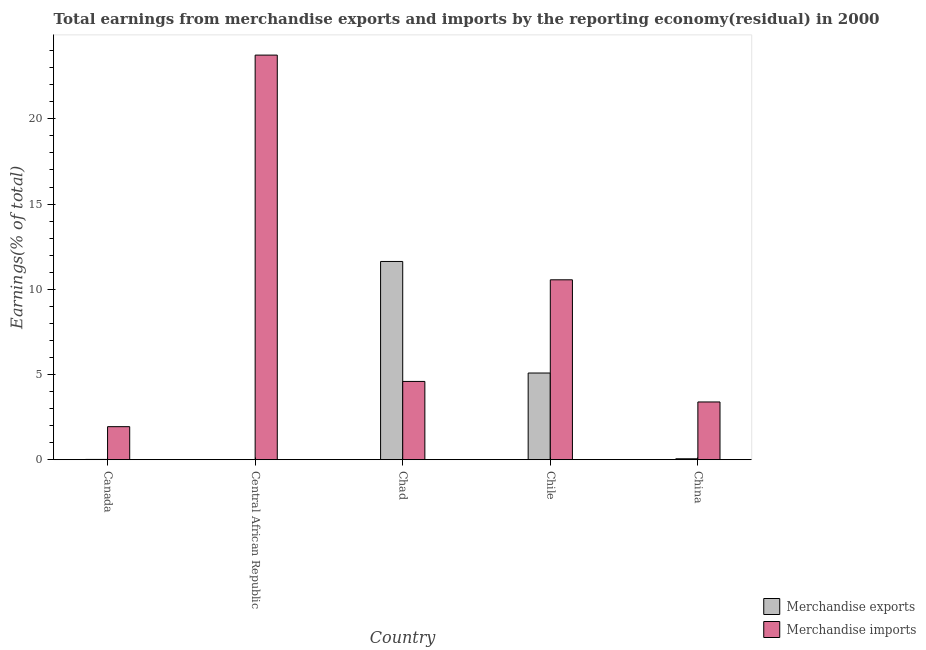How many different coloured bars are there?
Provide a succinct answer. 2. How many bars are there on the 2nd tick from the left?
Provide a succinct answer. 2. What is the label of the 3rd group of bars from the left?
Offer a very short reply. Chad. In how many cases, is the number of bars for a given country not equal to the number of legend labels?
Your answer should be very brief. 0. What is the earnings from merchandise exports in Central African Republic?
Your response must be concise. 0. Across all countries, what is the maximum earnings from merchandise imports?
Your answer should be compact. 23.74. Across all countries, what is the minimum earnings from merchandise imports?
Offer a terse response. 1.94. In which country was the earnings from merchandise exports maximum?
Your answer should be very brief. Chad. What is the total earnings from merchandise imports in the graph?
Your response must be concise. 44.21. What is the difference between the earnings from merchandise exports in Chad and that in China?
Give a very brief answer. 11.58. What is the difference between the earnings from merchandise imports in Chad and the earnings from merchandise exports in Canada?
Ensure brevity in your answer.  4.58. What is the average earnings from merchandise imports per country?
Offer a terse response. 8.84. What is the difference between the earnings from merchandise exports and earnings from merchandise imports in Chad?
Make the answer very short. 7.04. In how many countries, is the earnings from merchandise imports greater than 2 %?
Ensure brevity in your answer.  4. What is the ratio of the earnings from merchandise exports in Central African Republic to that in Chile?
Your response must be concise. 0. Is the difference between the earnings from merchandise exports in Chad and China greater than the difference between the earnings from merchandise imports in Chad and China?
Provide a short and direct response. Yes. What is the difference between the highest and the second highest earnings from merchandise exports?
Offer a very short reply. 6.55. What is the difference between the highest and the lowest earnings from merchandise imports?
Make the answer very short. 21.8. Is the sum of the earnings from merchandise imports in Canada and China greater than the maximum earnings from merchandise exports across all countries?
Your answer should be compact. No. What does the 2nd bar from the right in Central African Republic represents?
Ensure brevity in your answer.  Merchandise exports. How many bars are there?
Keep it short and to the point. 10. What is the difference between two consecutive major ticks on the Y-axis?
Offer a very short reply. 5. Does the graph contain any zero values?
Provide a short and direct response. No. Does the graph contain grids?
Your response must be concise. No. How many legend labels are there?
Provide a succinct answer. 2. What is the title of the graph?
Make the answer very short. Total earnings from merchandise exports and imports by the reporting economy(residual) in 2000. What is the label or title of the Y-axis?
Keep it short and to the point. Earnings(% of total). What is the Earnings(% of total) of Merchandise exports in Canada?
Offer a terse response. 0.02. What is the Earnings(% of total) of Merchandise imports in Canada?
Provide a short and direct response. 1.94. What is the Earnings(% of total) in Merchandise exports in Central African Republic?
Provide a succinct answer. 0. What is the Earnings(% of total) of Merchandise imports in Central African Republic?
Your answer should be compact. 23.74. What is the Earnings(% of total) of Merchandise exports in Chad?
Keep it short and to the point. 11.63. What is the Earnings(% of total) in Merchandise imports in Chad?
Your answer should be very brief. 4.59. What is the Earnings(% of total) in Merchandise exports in Chile?
Provide a short and direct response. 5.09. What is the Earnings(% of total) of Merchandise imports in Chile?
Your answer should be compact. 10.56. What is the Earnings(% of total) of Merchandise exports in China?
Your response must be concise. 0.05. What is the Earnings(% of total) in Merchandise imports in China?
Your answer should be very brief. 3.39. Across all countries, what is the maximum Earnings(% of total) of Merchandise exports?
Offer a very short reply. 11.63. Across all countries, what is the maximum Earnings(% of total) of Merchandise imports?
Offer a terse response. 23.74. Across all countries, what is the minimum Earnings(% of total) of Merchandise exports?
Your response must be concise. 0. Across all countries, what is the minimum Earnings(% of total) of Merchandise imports?
Provide a succinct answer. 1.94. What is the total Earnings(% of total) of Merchandise exports in the graph?
Provide a succinct answer. 16.79. What is the total Earnings(% of total) in Merchandise imports in the graph?
Offer a very short reply. 44.21. What is the difference between the Earnings(% of total) in Merchandise exports in Canada and that in Central African Republic?
Your answer should be compact. 0.01. What is the difference between the Earnings(% of total) of Merchandise imports in Canada and that in Central African Republic?
Give a very brief answer. -21.8. What is the difference between the Earnings(% of total) in Merchandise exports in Canada and that in Chad?
Ensure brevity in your answer.  -11.62. What is the difference between the Earnings(% of total) of Merchandise imports in Canada and that in Chad?
Provide a succinct answer. -2.65. What is the difference between the Earnings(% of total) of Merchandise exports in Canada and that in Chile?
Your answer should be compact. -5.07. What is the difference between the Earnings(% of total) in Merchandise imports in Canada and that in Chile?
Your answer should be compact. -8.62. What is the difference between the Earnings(% of total) in Merchandise exports in Canada and that in China?
Your answer should be very brief. -0.04. What is the difference between the Earnings(% of total) of Merchandise imports in Canada and that in China?
Offer a terse response. -1.45. What is the difference between the Earnings(% of total) of Merchandise exports in Central African Republic and that in Chad?
Keep it short and to the point. -11.63. What is the difference between the Earnings(% of total) of Merchandise imports in Central African Republic and that in Chad?
Provide a succinct answer. 19.15. What is the difference between the Earnings(% of total) of Merchandise exports in Central African Republic and that in Chile?
Your answer should be compact. -5.08. What is the difference between the Earnings(% of total) of Merchandise imports in Central African Republic and that in Chile?
Keep it short and to the point. 13.18. What is the difference between the Earnings(% of total) in Merchandise exports in Central African Republic and that in China?
Offer a terse response. -0.05. What is the difference between the Earnings(% of total) in Merchandise imports in Central African Republic and that in China?
Your answer should be very brief. 20.35. What is the difference between the Earnings(% of total) in Merchandise exports in Chad and that in Chile?
Offer a terse response. 6.55. What is the difference between the Earnings(% of total) in Merchandise imports in Chad and that in Chile?
Give a very brief answer. -5.96. What is the difference between the Earnings(% of total) in Merchandise exports in Chad and that in China?
Ensure brevity in your answer.  11.58. What is the difference between the Earnings(% of total) in Merchandise imports in Chad and that in China?
Ensure brevity in your answer.  1.2. What is the difference between the Earnings(% of total) in Merchandise exports in Chile and that in China?
Make the answer very short. 5.03. What is the difference between the Earnings(% of total) in Merchandise imports in Chile and that in China?
Keep it short and to the point. 7.17. What is the difference between the Earnings(% of total) of Merchandise exports in Canada and the Earnings(% of total) of Merchandise imports in Central African Republic?
Keep it short and to the point. -23.72. What is the difference between the Earnings(% of total) in Merchandise exports in Canada and the Earnings(% of total) in Merchandise imports in Chad?
Your response must be concise. -4.58. What is the difference between the Earnings(% of total) in Merchandise exports in Canada and the Earnings(% of total) in Merchandise imports in Chile?
Your answer should be compact. -10.54. What is the difference between the Earnings(% of total) of Merchandise exports in Canada and the Earnings(% of total) of Merchandise imports in China?
Offer a terse response. -3.37. What is the difference between the Earnings(% of total) of Merchandise exports in Central African Republic and the Earnings(% of total) of Merchandise imports in Chad?
Your answer should be very brief. -4.59. What is the difference between the Earnings(% of total) of Merchandise exports in Central African Republic and the Earnings(% of total) of Merchandise imports in Chile?
Your response must be concise. -10.55. What is the difference between the Earnings(% of total) of Merchandise exports in Central African Republic and the Earnings(% of total) of Merchandise imports in China?
Give a very brief answer. -3.39. What is the difference between the Earnings(% of total) in Merchandise exports in Chad and the Earnings(% of total) in Merchandise imports in Chile?
Offer a terse response. 1.08. What is the difference between the Earnings(% of total) in Merchandise exports in Chad and the Earnings(% of total) in Merchandise imports in China?
Give a very brief answer. 8.24. What is the difference between the Earnings(% of total) of Merchandise exports in Chile and the Earnings(% of total) of Merchandise imports in China?
Your answer should be compact. 1.7. What is the average Earnings(% of total) of Merchandise exports per country?
Provide a short and direct response. 3.36. What is the average Earnings(% of total) of Merchandise imports per country?
Keep it short and to the point. 8.84. What is the difference between the Earnings(% of total) of Merchandise exports and Earnings(% of total) of Merchandise imports in Canada?
Your answer should be very brief. -1.92. What is the difference between the Earnings(% of total) in Merchandise exports and Earnings(% of total) in Merchandise imports in Central African Republic?
Your answer should be very brief. -23.74. What is the difference between the Earnings(% of total) of Merchandise exports and Earnings(% of total) of Merchandise imports in Chad?
Your answer should be compact. 7.04. What is the difference between the Earnings(% of total) in Merchandise exports and Earnings(% of total) in Merchandise imports in Chile?
Your answer should be compact. -5.47. What is the difference between the Earnings(% of total) of Merchandise exports and Earnings(% of total) of Merchandise imports in China?
Give a very brief answer. -3.33. What is the ratio of the Earnings(% of total) of Merchandise exports in Canada to that in Central African Republic?
Your answer should be very brief. 8.55. What is the ratio of the Earnings(% of total) in Merchandise imports in Canada to that in Central African Republic?
Make the answer very short. 0.08. What is the ratio of the Earnings(% of total) in Merchandise exports in Canada to that in Chad?
Your response must be concise. 0. What is the ratio of the Earnings(% of total) of Merchandise imports in Canada to that in Chad?
Ensure brevity in your answer.  0.42. What is the ratio of the Earnings(% of total) in Merchandise exports in Canada to that in Chile?
Your answer should be compact. 0. What is the ratio of the Earnings(% of total) of Merchandise imports in Canada to that in Chile?
Your answer should be very brief. 0.18. What is the ratio of the Earnings(% of total) of Merchandise exports in Canada to that in China?
Give a very brief answer. 0.28. What is the ratio of the Earnings(% of total) in Merchandise imports in Canada to that in China?
Provide a short and direct response. 0.57. What is the ratio of the Earnings(% of total) in Merchandise imports in Central African Republic to that in Chad?
Your response must be concise. 5.17. What is the ratio of the Earnings(% of total) of Merchandise imports in Central African Republic to that in Chile?
Provide a short and direct response. 2.25. What is the ratio of the Earnings(% of total) of Merchandise exports in Central African Republic to that in China?
Give a very brief answer. 0.03. What is the ratio of the Earnings(% of total) in Merchandise imports in Central African Republic to that in China?
Make the answer very short. 7.01. What is the ratio of the Earnings(% of total) of Merchandise exports in Chad to that in Chile?
Your response must be concise. 2.29. What is the ratio of the Earnings(% of total) in Merchandise imports in Chad to that in Chile?
Your response must be concise. 0.44. What is the ratio of the Earnings(% of total) of Merchandise exports in Chad to that in China?
Offer a terse response. 214.69. What is the ratio of the Earnings(% of total) in Merchandise imports in Chad to that in China?
Provide a succinct answer. 1.36. What is the ratio of the Earnings(% of total) of Merchandise exports in Chile to that in China?
Provide a succinct answer. 93.86. What is the ratio of the Earnings(% of total) of Merchandise imports in Chile to that in China?
Provide a short and direct response. 3.12. What is the difference between the highest and the second highest Earnings(% of total) in Merchandise exports?
Offer a terse response. 6.55. What is the difference between the highest and the second highest Earnings(% of total) of Merchandise imports?
Offer a terse response. 13.18. What is the difference between the highest and the lowest Earnings(% of total) in Merchandise exports?
Your answer should be compact. 11.63. What is the difference between the highest and the lowest Earnings(% of total) of Merchandise imports?
Your response must be concise. 21.8. 